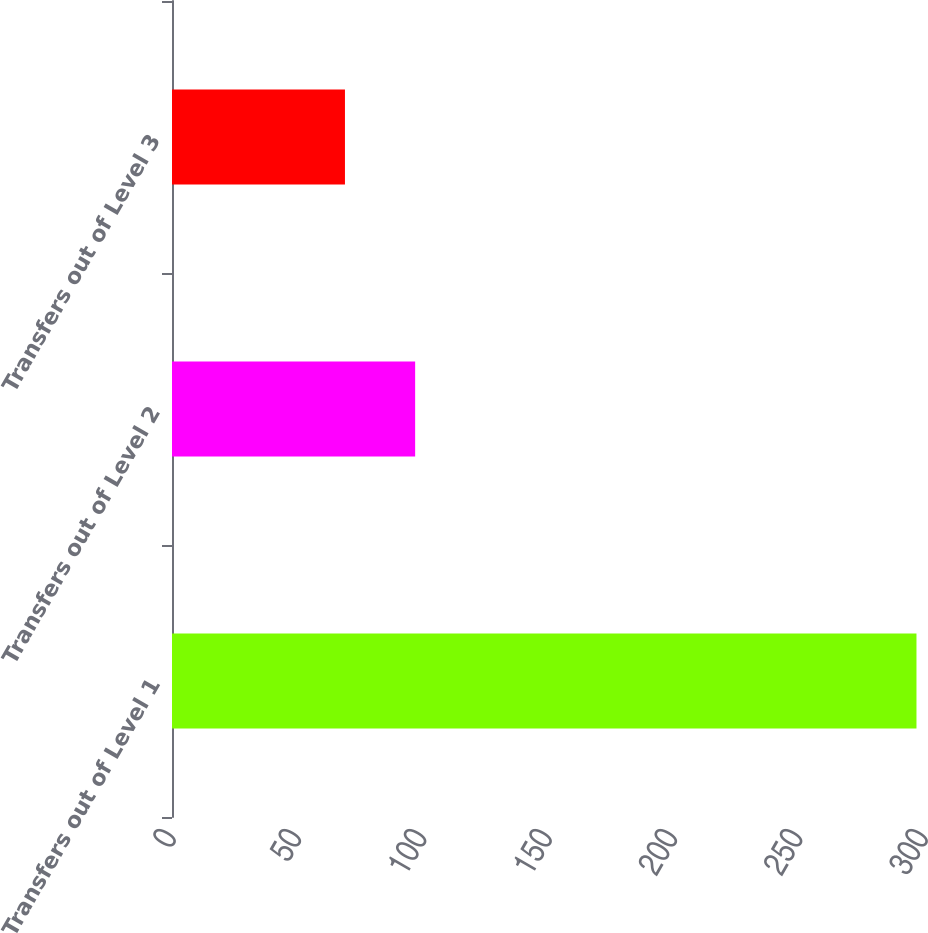Convert chart to OTSL. <chart><loc_0><loc_0><loc_500><loc_500><bar_chart><fcel>Transfers out of Level 1<fcel>Transfers out of Level 2<fcel>Transfers out of Level 3<nl><fcel>297<fcel>97<fcel>69<nl></chart> 